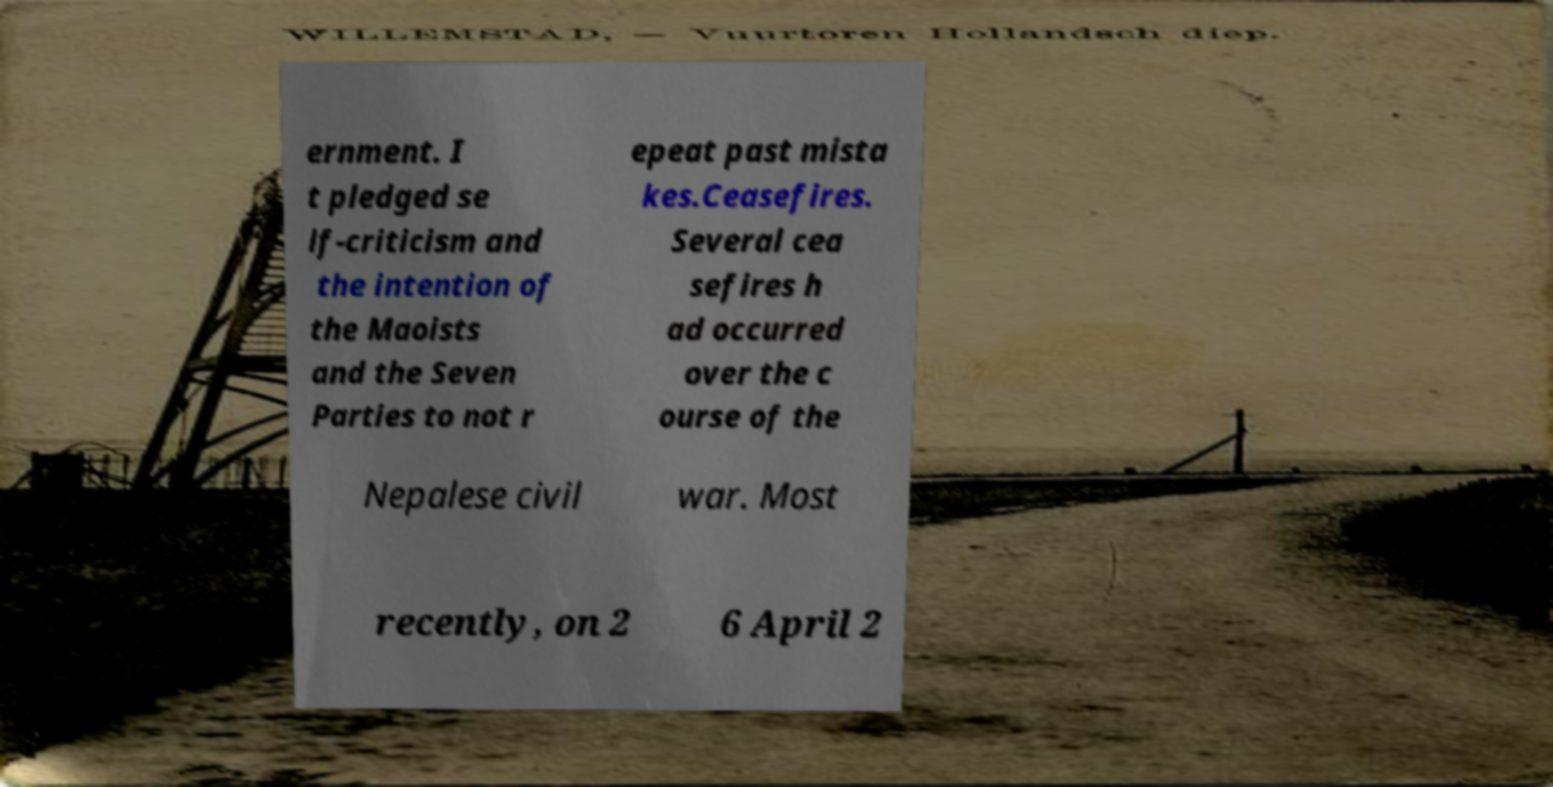Please identify and transcribe the text found in this image. ernment. I t pledged se lf-criticism and the intention of the Maoists and the Seven Parties to not r epeat past mista kes.Ceasefires. Several cea sefires h ad occurred over the c ourse of the Nepalese civil war. Most recently, on 2 6 April 2 